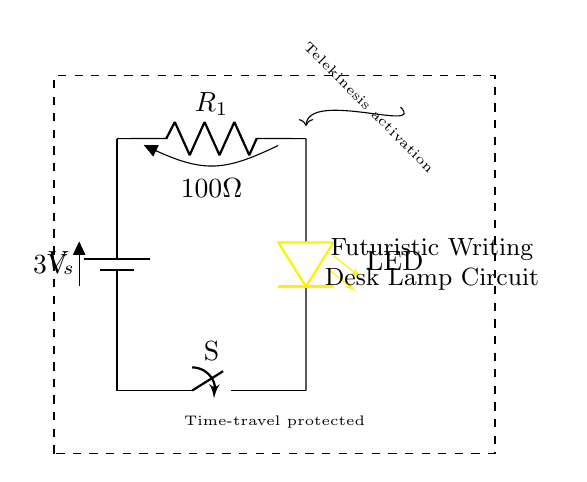What is the voltage of this circuit? The voltage is three volts, indicated by the battery label. This is the potential difference supplied by the power source in the circuit.
Answer: three volts What type of switch is used in this circuit? The circuit includes a simple on-off switch, denoted as "S." This type of switch can control the flow of current through the circuit, allowing the lamp to be turned on or off.
Answer: on-off switch What is the resistance value in this circuit? The resistance in the circuit is one hundred ohms, as shown next to the resistor label "R1." This component limits the current flowing to the LED to prevent damage.
Answer: one hundred ohms Which component is responsible for producing light in this circuit? The light-emitting diode, labeled as "LED," is responsible for producing light. When current flows through it, it emits light due to electroluminescence.
Answer: LED What is the purpose of the current-limiting resistor? Its purpose is to limit the current flowing through the LED to a safe level and prevent it from burning out. The resistance value is crucial for maintaining the functionality and longevity of the LED.
Answer: limit current How does telekinesis activation affect the circuit? The telekinesis activation symbol suggests a feature that allows the lamp to be turned on or off without physical interaction, implying an advanced control mechanism perhaps related to futuristic features.
Answer: advanced control 